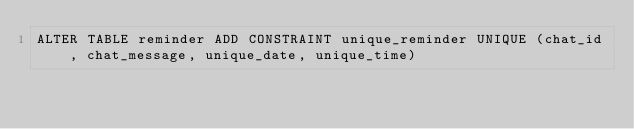<code> <loc_0><loc_0><loc_500><loc_500><_SQL_>ALTER TABLE reminder ADD CONSTRAINT unique_reminder UNIQUE (chat_id, chat_message, unique_date, unique_time)</code> 